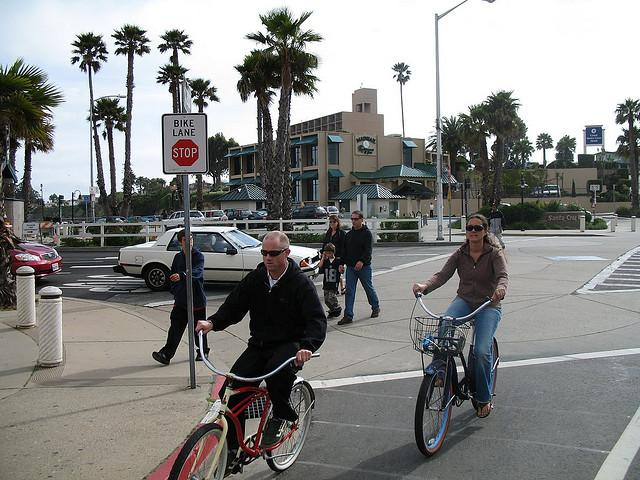What kind of sign is shown? Please explain your reasoning. traffic. You can tell by the shape and the wording as to what type of sign is being shown. 